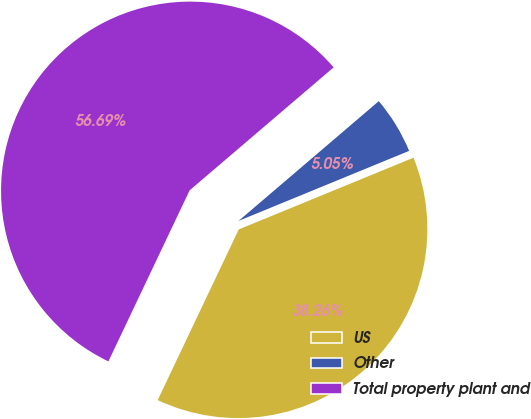Convert chart. <chart><loc_0><loc_0><loc_500><loc_500><pie_chart><fcel>US<fcel>Other<fcel>Total property plant and<nl><fcel>38.26%<fcel>5.05%<fcel>56.7%<nl></chart> 